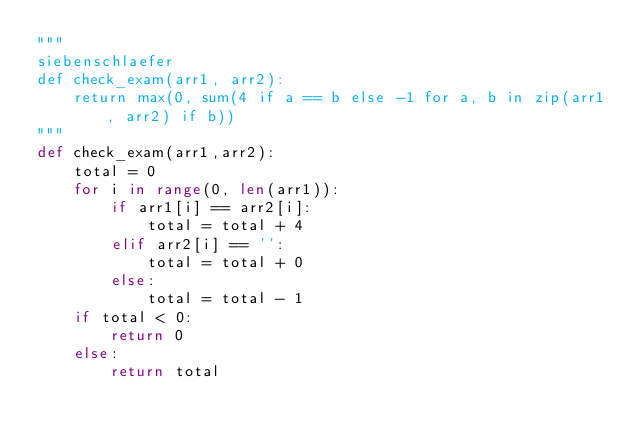<code> <loc_0><loc_0><loc_500><loc_500><_Python_>"""
siebenschlaefer
def check_exam(arr1, arr2):
    return max(0, sum(4 if a == b else -1 for a, b in zip(arr1, arr2) if b))
"""
def check_exam(arr1,arr2):
    total = 0
    for i in range(0, len(arr1)):
        if arr1[i] == arr2[i]:
            total = total + 4
        elif arr2[i] == '':
            total = total + 0
        else:
            total = total - 1
    if total < 0:
        return 0
    else:
        return total
</code> 